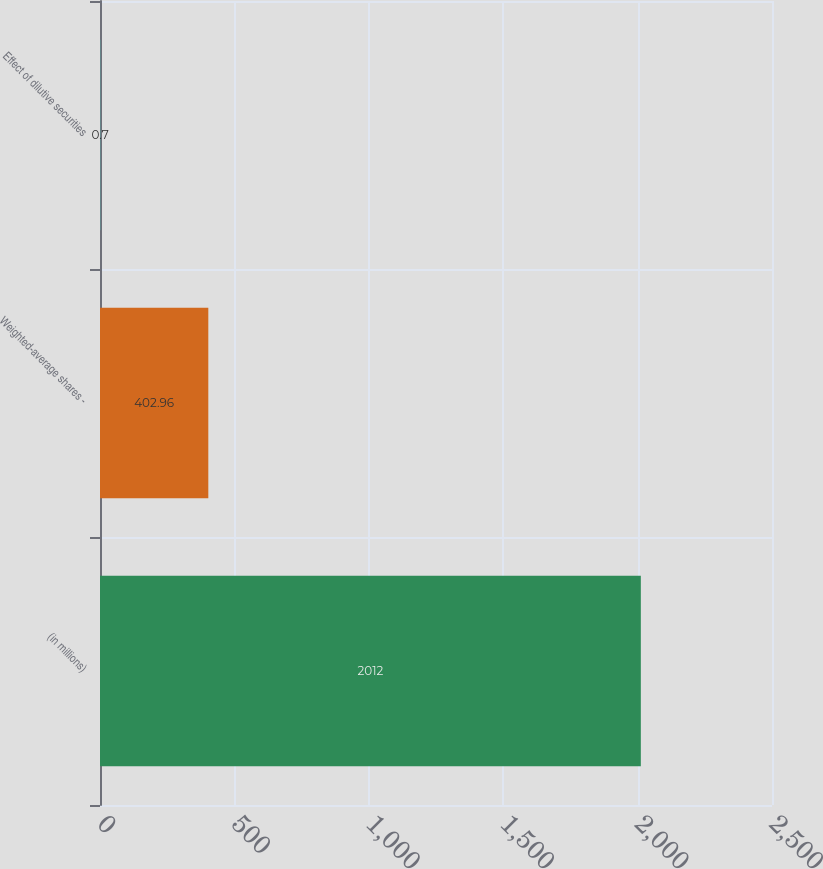<chart> <loc_0><loc_0><loc_500><loc_500><bar_chart><fcel>(in millions)<fcel>Weighted-average shares -<fcel>Effect of dilutive securities<nl><fcel>2012<fcel>402.96<fcel>0.7<nl></chart> 